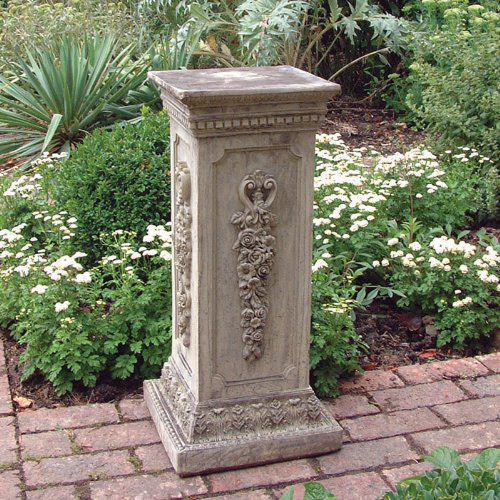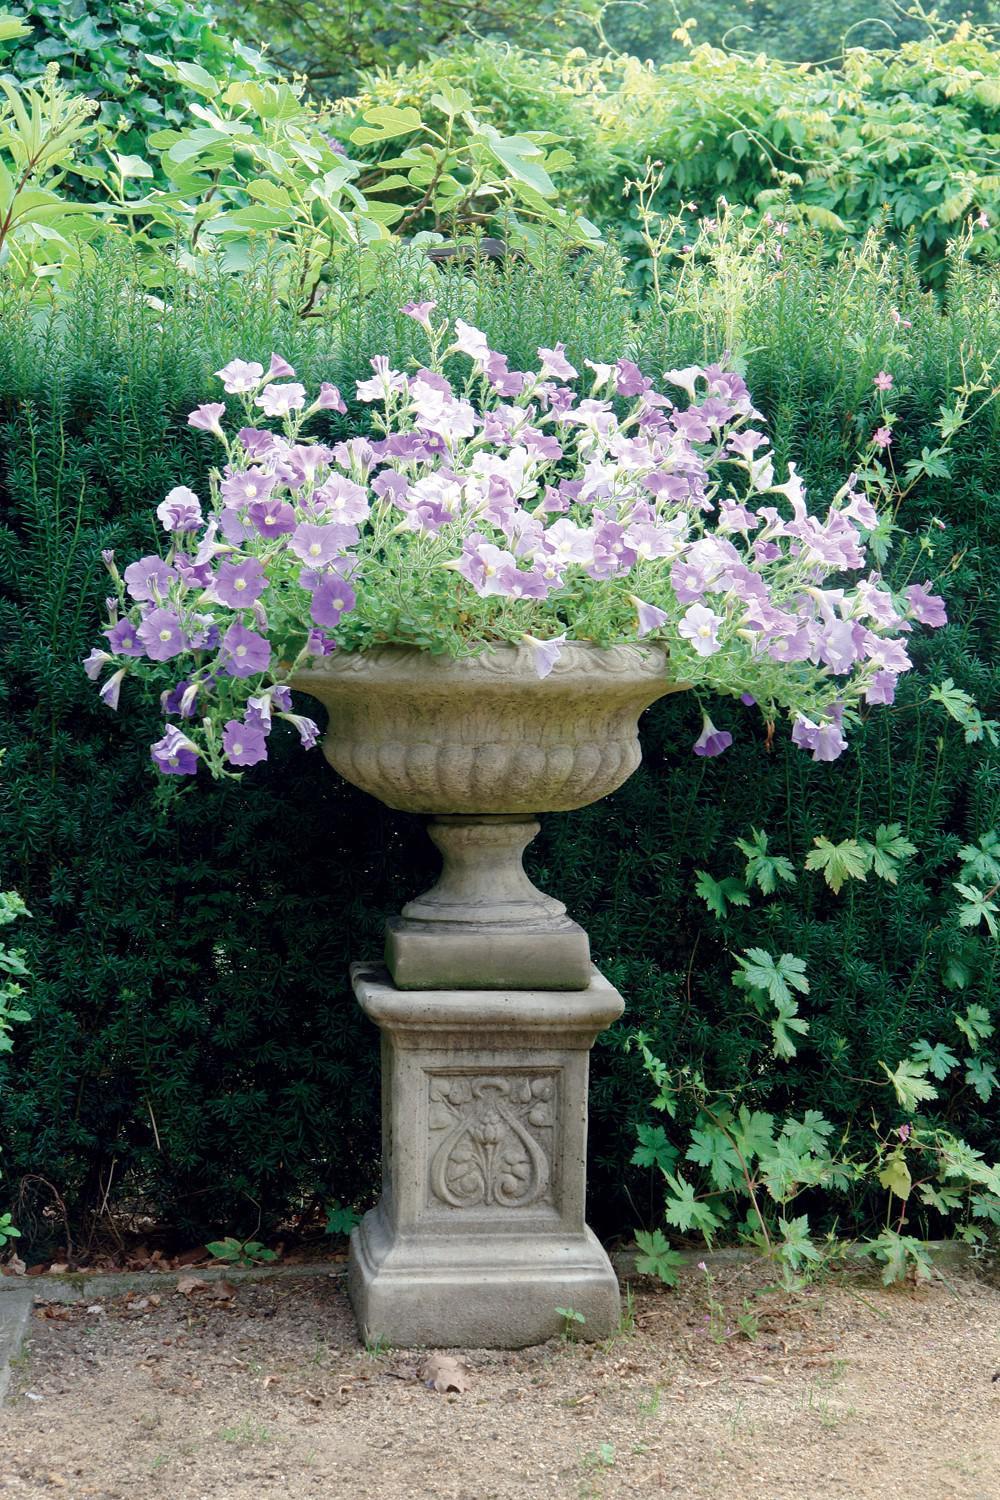The first image is the image on the left, the second image is the image on the right. Examine the images to the left and right. Is the description "There are no flowers on the pedestal on the left." accurate? Answer yes or no. Yes. The first image is the image on the left, the second image is the image on the right. Considering the images on both sides, is "An image shows a bowl-shaped stone-look planter on a column pedestal, with a plant in the bowl." valid? Answer yes or no. Yes. 